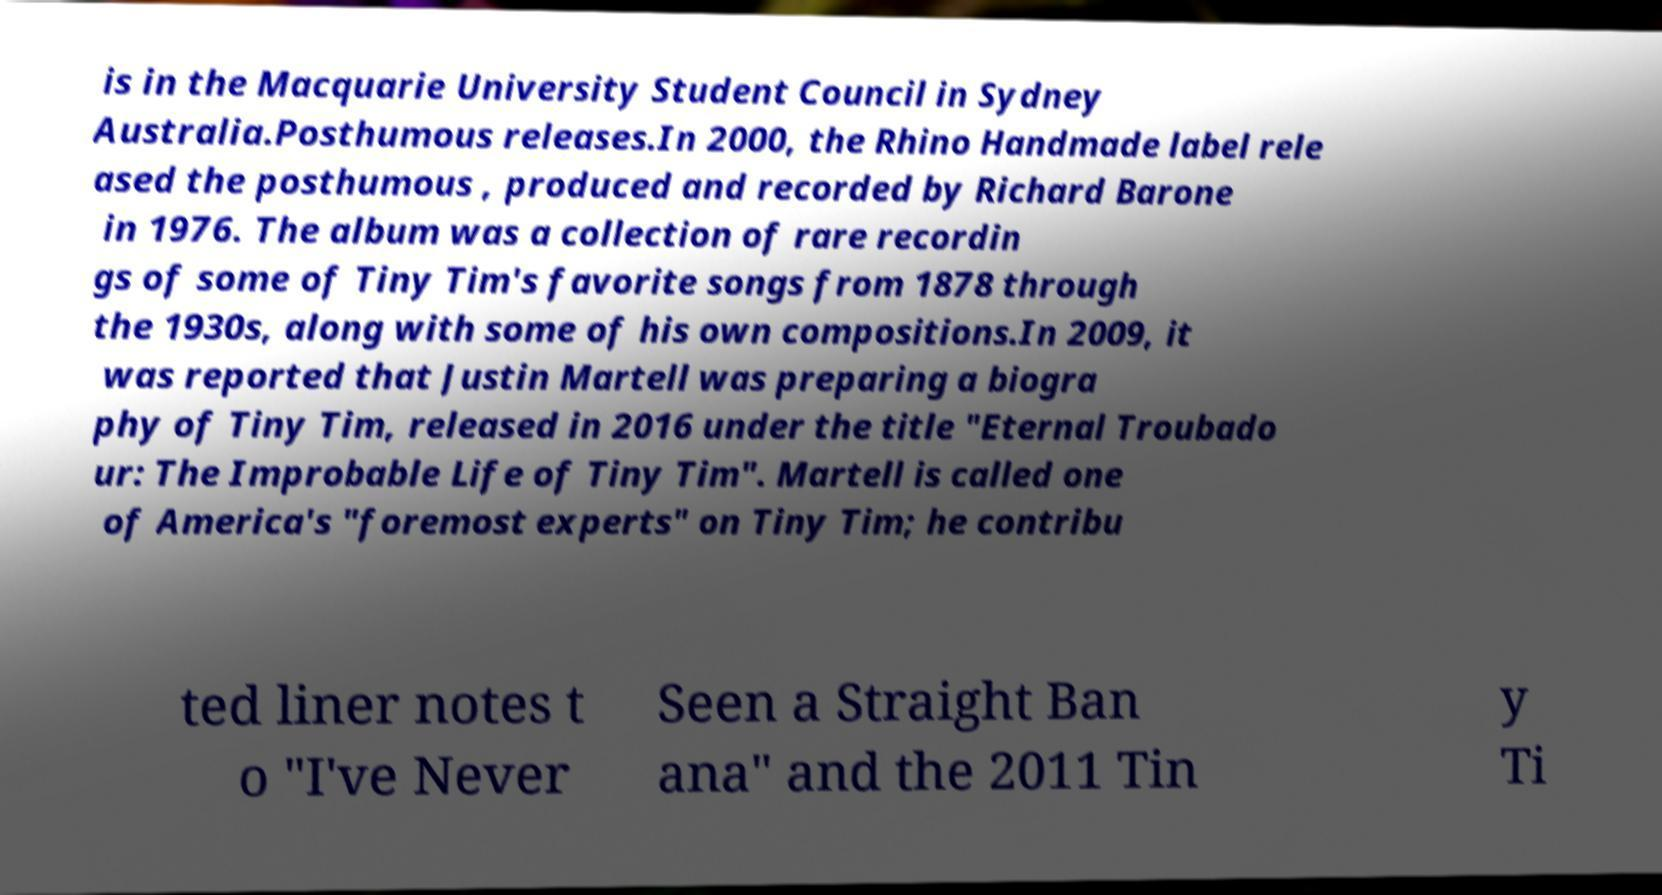What messages or text are displayed in this image? I need them in a readable, typed format. is in the Macquarie University Student Council in Sydney Australia.Posthumous releases.In 2000, the Rhino Handmade label rele ased the posthumous , produced and recorded by Richard Barone in 1976. The album was a collection of rare recordin gs of some of Tiny Tim's favorite songs from 1878 through the 1930s, along with some of his own compositions.In 2009, it was reported that Justin Martell was preparing a biogra phy of Tiny Tim, released in 2016 under the title "Eternal Troubado ur: The Improbable Life of Tiny Tim". Martell is called one of America's "foremost experts" on Tiny Tim; he contribu ted liner notes t o "I've Never Seen a Straight Ban ana" and the 2011 Tin y Ti 